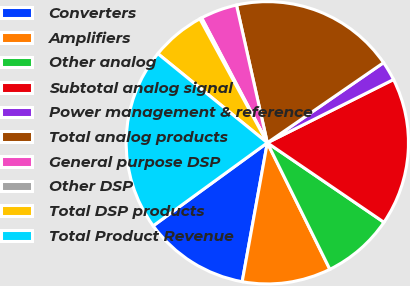<chart> <loc_0><loc_0><loc_500><loc_500><pie_chart><fcel>Converters<fcel>Amplifiers<fcel>Other analog<fcel>Subtotal analog signal<fcel>Power management & reference<fcel>Total analog products<fcel>General purpose DSP<fcel>Other DSP<fcel>Total DSP products<fcel>Total Product Revenue<nl><fcel>12.14%<fcel>10.16%<fcel>8.17%<fcel>16.92%<fcel>2.21%<fcel>18.9%<fcel>4.2%<fcel>0.23%<fcel>6.19%<fcel>20.89%<nl></chart> 